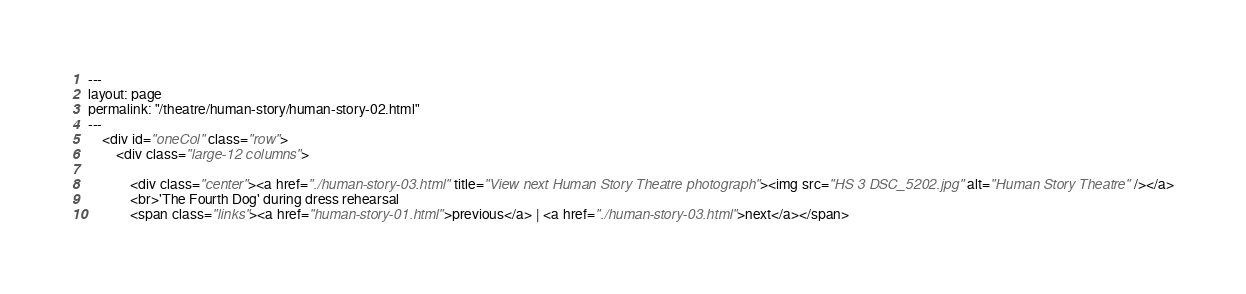Convert code to text. <code><loc_0><loc_0><loc_500><loc_500><_HTML_>---
layout: page
permalink: "/theatre/human-story/human-story-02.html"
---
	<div id="oneCol" class="row">
		<div class="large-12 columns">

			<div class="center"><a href="./human-story-03.html" title="View next Human Story Theatre photograph"><img src="HS 3 DSC_5202.jpg" alt="Human Story Theatre" /></a>
			<br>'The Fourth Dog' during dress rehearsal
			<span class="links"><a href="human-story-01.html">previous</a> | <a href="./human-story-03.html">next</a></span></code> 